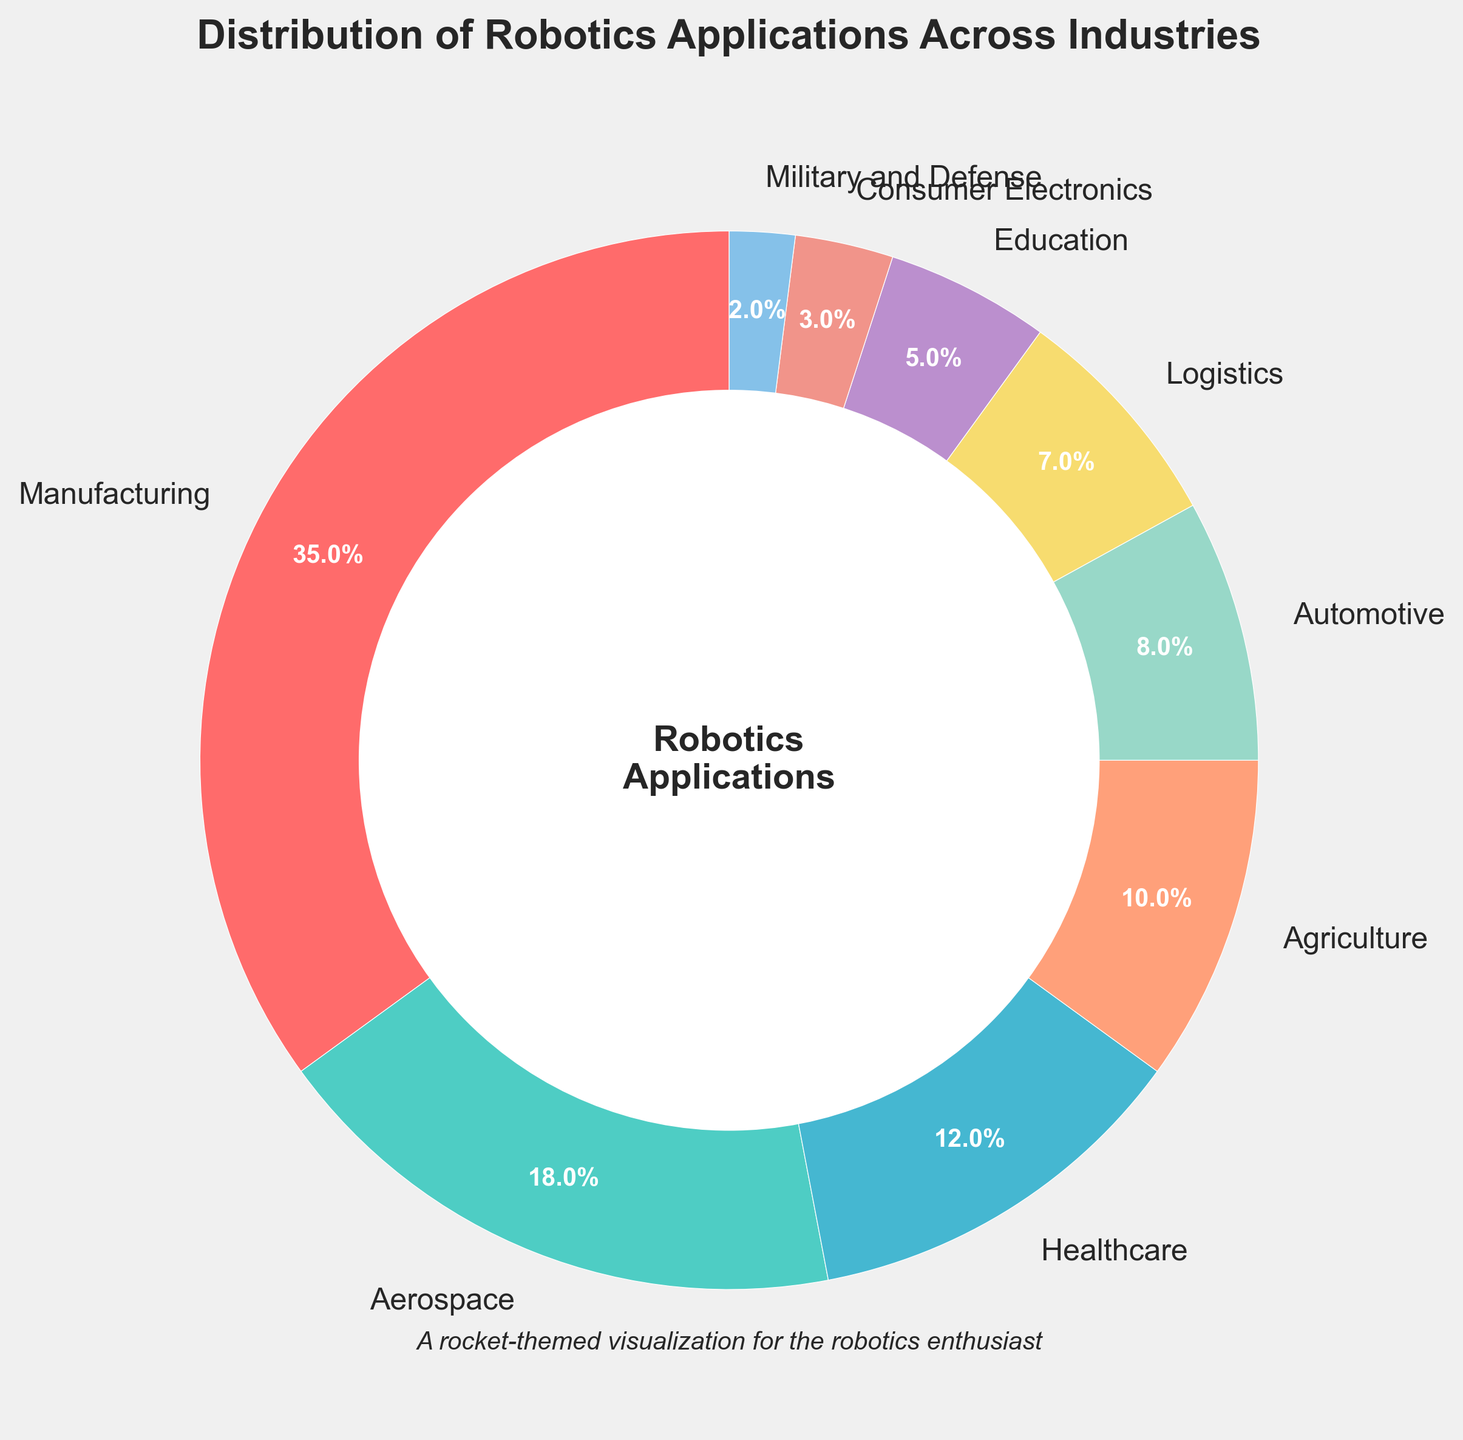Which industry has the highest percentage of robotics applications? The pie chart shows different industries with their respective percentages. By looking at the chart, we see that Manufacturing has the highest percentage.
Answer: Manufacturing Which two industries together account for more than 50% of the robotics applications? By examining the pie chart percentages, we add the top two values, Manufacturing (35%) and Aerospace (18%). Their sum is 35% + 18% = 53%, which is more than 50%.
Answer: Manufacturing and Aerospace How much greater is the robotics application percentage in Healthcare compared to Agricultural? By comparing the percentages shown in the pie chart, Healthcare has 12% and Agriculture has 10%. The difference is 12% - 10% = 2%.
Answer: 2% What is the combined percentage of the industries with less than 10% each? The industries with less than 10% are Agriculture (10%), Automotive (8%), Logistics (7%), Education (5%), Consumer Electronics (3%) and Military and Defense (2%). Adding these percentages together gives 10% + 8% + 7% + 5% + 3% + 2% = 35%.
Answer: 35% What industries share the same segment color close to green? By observing the pie chart, Logistics is colored close to green.
Answer: Logistics Which industries individually constitute a greater percentage than Healthcare? On examining the pie chart, only Manufacturing (35%) and Aerospace (18%) have a percentage greater than Healthcare (12%).
Answer: Manufacturing and Aerospace Between Aerospace and Automotive, which industry has a higher percentage, and by how much? Comparing the two industries, Aerospace has 18% and Automotive has 8%. The difference is 18% - 8% = 10%.
Answer: Aerospace by 10% What is the average percentage of robotics applications across all the industries? The total sum of all the percentages in the pie chart is 100%. There are 9 industries. The average percentage is calculated as 100% / 9 ≈ 11.1%.
Answer: 11.1% Which industry is represented with a wedge colored close to red? By analyzing the colors in the pie chart, Manufacturing is colored close to red.
Answer: Manufacturing What is the median percentage value of robotics applications in the listed industries? Sorting the percentages in ascending order: 2%, 3%, 5%, 7%, 8%, 10%, 12%, 18%, 35%. The middle value (median) in this list is the 5th one, which is 8%.
Answer: 8% 